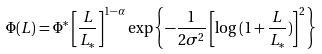<formula> <loc_0><loc_0><loc_500><loc_500>\Phi ( L ) = \Phi ^ { * } \left [ \frac { L } { L _ { * } } \right ] ^ { 1 - \alpha } \exp { \left \{ - \frac { 1 } { 2 \sigma ^ { 2 } } \left [ \log { ( 1 + \frac { L } { L _ { * } } ) } \right ] ^ { 2 } \right \} }</formula> 